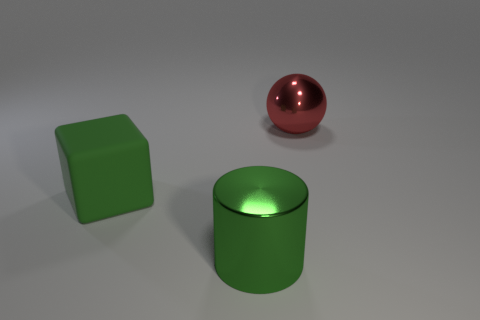There is a metallic object behind the large shiny object that is on the left side of the large red metallic thing; are there any big shiny objects that are left of it?
Give a very brief answer. Yes. What number of objects are either big objects that are in front of the green rubber block or green objects in front of the cube?
Your answer should be very brief. 1. Is the big thing that is to the left of the big green metal cylinder made of the same material as the red thing?
Make the answer very short. No. What is the thing that is both left of the big ball and behind the big green cylinder made of?
Provide a succinct answer. Rubber. The object that is right of the metal object on the left side of the red sphere is what color?
Your answer should be very brief. Red. There is a metallic object in front of the shiny object that is on the right side of the big shiny thing that is left of the red sphere; what is its color?
Ensure brevity in your answer.  Green. What number of objects are either tiny brown metal spheres or big shiny things?
Offer a very short reply. 2. How many large red metallic things are the same shape as the matte thing?
Offer a very short reply. 0. Is the big green cylinder made of the same material as the thing on the left side of the large green shiny object?
Offer a terse response. No. There is a cylinder that is made of the same material as the large red sphere; what is its size?
Offer a terse response. Large. 